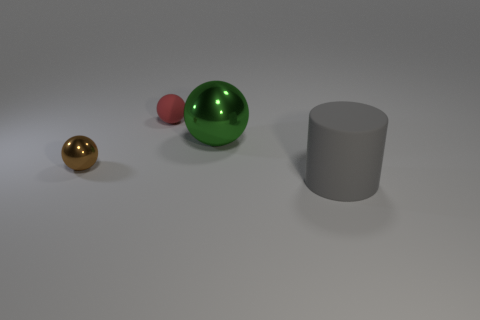Subtract all small metal balls. How many balls are left? 2 Add 2 green cylinders. How many objects exist? 6 Subtract all yellow spheres. Subtract all gray blocks. How many spheres are left? 3 Subtract all cylinders. How many objects are left? 3 Subtract all big gray cylinders. Subtract all brown metal spheres. How many objects are left? 2 Add 3 shiny things. How many shiny things are left? 5 Add 3 big objects. How many big objects exist? 5 Subtract 0 green cylinders. How many objects are left? 4 